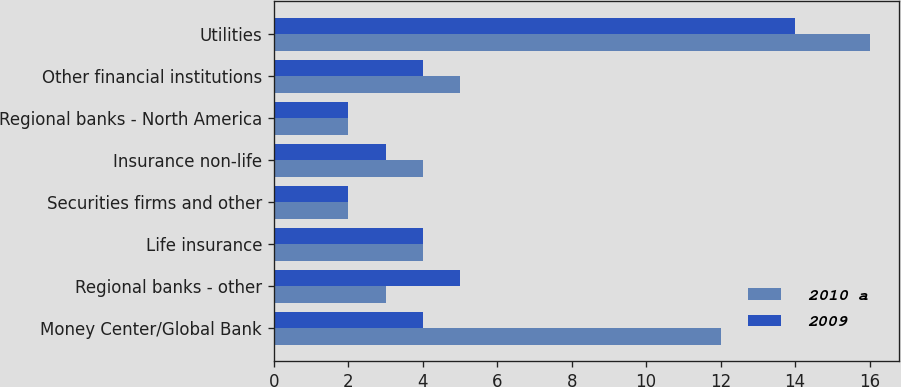Convert chart. <chart><loc_0><loc_0><loc_500><loc_500><stacked_bar_chart><ecel><fcel>Money Center/Global Bank<fcel>Regional banks - other<fcel>Life insurance<fcel>Securities firms and other<fcel>Insurance non-life<fcel>Regional banks - North America<fcel>Other financial institutions<fcel>Utilities<nl><fcel>2010 a<fcel>12<fcel>3<fcel>4<fcel>2<fcel>4<fcel>2<fcel>5<fcel>16<nl><fcel>2009<fcel>4<fcel>5<fcel>4<fcel>2<fcel>3<fcel>2<fcel>4<fcel>14<nl></chart> 